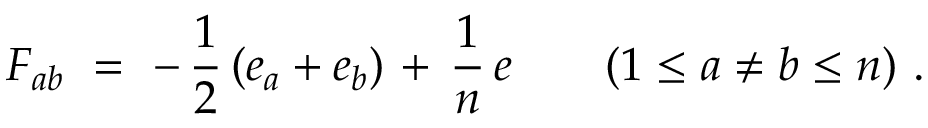<formula> <loc_0><loc_0><loc_500><loc_500>F _ { a b } = - \, { \frac { 1 } { 2 } } \left ( e _ { a } + e _ { b } \right ) \, + \, { \frac { 1 } { n } } \, e \quad ( 1 \leq a \neq b \leq n ) .</formula> 